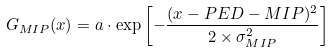Convert formula to latex. <formula><loc_0><loc_0><loc_500><loc_500>G _ { M I P } ( x ) = a \cdot \exp \left [ - \frac { ( x - P E D - M I P ) ^ { 2 } } { 2 \times \sigma _ { M I P } ^ { 2 } } \right ]</formula> 